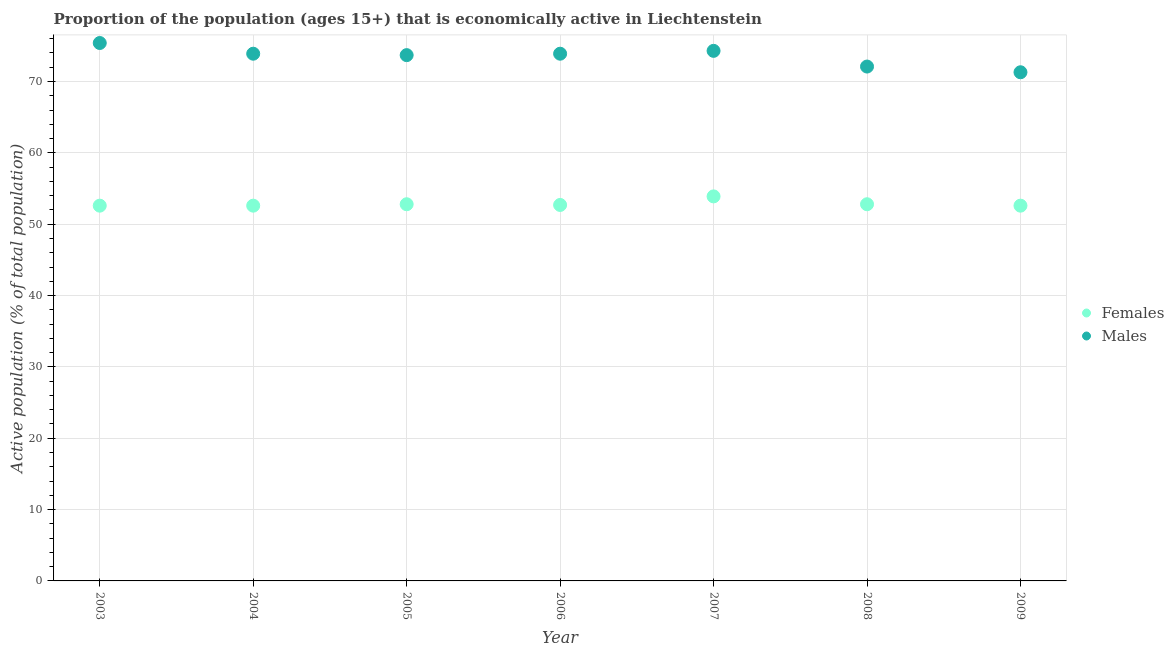How many different coloured dotlines are there?
Give a very brief answer. 2. What is the percentage of economically active male population in 2007?
Your response must be concise. 74.3. Across all years, what is the maximum percentage of economically active female population?
Keep it short and to the point. 53.9. Across all years, what is the minimum percentage of economically active male population?
Your answer should be very brief. 71.3. In which year was the percentage of economically active male population maximum?
Make the answer very short. 2003. In which year was the percentage of economically active female population minimum?
Your answer should be compact. 2003. What is the total percentage of economically active female population in the graph?
Ensure brevity in your answer.  370. What is the difference between the percentage of economically active female population in 2008 and that in 2009?
Offer a very short reply. 0.2. What is the difference between the percentage of economically active female population in 2004 and the percentage of economically active male population in 2005?
Keep it short and to the point. -21.1. What is the average percentage of economically active male population per year?
Offer a terse response. 73.51. In the year 2003, what is the difference between the percentage of economically active female population and percentage of economically active male population?
Ensure brevity in your answer.  -22.8. In how many years, is the percentage of economically active male population greater than 38 %?
Your answer should be very brief. 7. What is the ratio of the percentage of economically active female population in 2004 to that in 2006?
Provide a succinct answer. 1. Is the percentage of economically active female population in 2006 less than that in 2009?
Provide a succinct answer. No. What is the difference between the highest and the second highest percentage of economically active female population?
Offer a very short reply. 1.1. What is the difference between the highest and the lowest percentage of economically active male population?
Give a very brief answer. 4.1. Is the sum of the percentage of economically active male population in 2005 and 2009 greater than the maximum percentage of economically active female population across all years?
Provide a succinct answer. Yes. Is the percentage of economically active male population strictly greater than the percentage of economically active female population over the years?
Provide a short and direct response. Yes. Is the percentage of economically active male population strictly less than the percentage of economically active female population over the years?
Ensure brevity in your answer.  No. How many dotlines are there?
Keep it short and to the point. 2. How are the legend labels stacked?
Provide a short and direct response. Vertical. What is the title of the graph?
Give a very brief answer. Proportion of the population (ages 15+) that is economically active in Liechtenstein. Does "IMF concessional" appear as one of the legend labels in the graph?
Make the answer very short. No. What is the label or title of the Y-axis?
Make the answer very short. Active population (% of total population). What is the Active population (% of total population) of Females in 2003?
Make the answer very short. 52.6. What is the Active population (% of total population) in Males in 2003?
Provide a succinct answer. 75.4. What is the Active population (% of total population) of Females in 2004?
Offer a very short reply. 52.6. What is the Active population (% of total population) in Males in 2004?
Your answer should be compact. 73.9. What is the Active population (% of total population) of Females in 2005?
Give a very brief answer. 52.8. What is the Active population (% of total population) of Males in 2005?
Your answer should be very brief. 73.7. What is the Active population (% of total population) in Females in 2006?
Make the answer very short. 52.7. What is the Active population (% of total population) in Males in 2006?
Offer a terse response. 73.9. What is the Active population (% of total population) in Females in 2007?
Make the answer very short. 53.9. What is the Active population (% of total population) in Males in 2007?
Offer a very short reply. 74.3. What is the Active population (% of total population) in Females in 2008?
Ensure brevity in your answer.  52.8. What is the Active population (% of total population) in Males in 2008?
Give a very brief answer. 72.1. What is the Active population (% of total population) of Females in 2009?
Your response must be concise. 52.6. What is the Active population (% of total population) in Males in 2009?
Offer a very short reply. 71.3. Across all years, what is the maximum Active population (% of total population) in Females?
Ensure brevity in your answer.  53.9. Across all years, what is the maximum Active population (% of total population) of Males?
Make the answer very short. 75.4. Across all years, what is the minimum Active population (% of total population) of Females?
Your answer should be compact. 52.6. Across all years, what is the minimum Active population (% of total population) of Males?
Make the answer very short. 71.3. What is the total Active population (% of total population) of Females in the graph?
Offer a very short reply. 370. What is the total Active population (% of total population) in Males in the graph?
Keep it short and to the point. 514.6. What is the difference between the Active population (% of total population) of Females in 2003 and that in 2005?
Provide a short and direct response. -0.2. What is the difference between the Active population (% of total population) of Females in 2003 and that in 2007?
Your answer should be compact. -1.3. What is the difference between the Active population (% of total population) in Females in 2003 and that in 2008?
Give a very brief answer. -0.2. What is the difference between the Active population (% of total population) of Females in 2003 and that in 2009?
Offer a terse response. 0. What is the difference between the Active population (% of total population) in Males in 2004 and that in 2006?
Provide a succinct answer. 0. What is the difference between the Active population (% of total population) of Males in 2004 and that in 2007?
Provide a succinct answer. -0.4. What is the difference between the Active population (% of total population) of Males in 2004 and that in 2009?
Offer a very short reply. 2.6. What is the difference between the Active population (% of total population) in Females in 2005 and that in 2009?
Provide a short and direct response. 0.2. What is the difference between the Active population (% of total population) in Males in 2006 and that in 2007?
Provide a succinct answer. -0.4. What is the difference between the Active population (% of total population) in Males in 2006 and that in 2008?
Provide a short and direct response. 1.8. What is the difference between the Active population (% of total population) of Males in 2007 and that in 2008?
Ensure brevity in your answer.  2.2. What is the difference between the Active population (% of total population) of Females in 2007 and that in 2009?
Provide a succinct answer. 1.3. What is the difference between the Active population (% of total population) in Males in 2007 and that in 2009?
Provide a short and direct response. 3. What is the difference between the Active population (% of total population) in Females in 2003 and the Active population (% of total population) in Males in 2004?
Ensure brevity in your answer.  -21.3. What is the difference between the Active population (% of total population) of Females in 2003 and the Active population (% of total population) of Males in 2005?
Provide a succinct answer. -21.1. What is the difference between the Active population (% of total population) of Females in 2003 and the Active population (% of total population) of Males in 2006?
Offer a terse response. -21.3. What is the difference between the Active population (% of total population) of Females in 2003 and the Active population (% of total population) of Males in 2007?
Your response must be concise. -21.7. What is the difference between the Active population (% of total population) of Females in 2003 and the Active population (% of total population) of Males in 2008?
Provide a short and direct response. -19.5. What is the difference between the Active population (% of total population) of Females in 2003 and the Active population (% of total population) of Males in 2009?
Provide a succinct answer. -18.7. What is the difference between the Active population (% of total population) in Females in 2004 and the Active population (% of total population) in Males in 2005?
Ensure brevity in your answer.  -21.1. What is the difference between the Active population (% of total population) of Females in 2004 and the Active population (% of total population) of Males in 2006?
Make the answer very short. -21.3. What is the difference between the Active population (% of total population) of Females in 2004 and the Active population (% of total population) of Males in 2007?
Make the answer very short. -21.7. What is the difference between the Active population (% of total population) of Females in 2004 and the Active population (% of total population) of Males in 2008?
Offer a terse response. -19.5. What is the difference between the Active population (% of total population) of Females in 2004 and the Active population (% of total population) of Males in 2009?
Make the answer very short. -18.7. What is the difference between the Active population (% of total population) of Females in 2005 and the Active population (% of total population) of Males in 2006?
Provide a succinct answer. -21.1. What is the difference between the Active population (% of total population) of Females in 2005 and the Active population (% of total population) of Males in 2007?
Your response must be concise. -21.5. What is the difference between the Active population (% of total population) in Females in 2005 and the Active population (% of total population) in Males in 2008?
Give a very brief answer. -19.3. What is the difference between the Active population (% of total population) in Females in 2005 and the Active population (% of total population) in Males in 2009?
Your response must be concise. -18.5. What is the difference between the Active population (% of total population) in Females in 2006 and the Active population (% of total population) in Males in 2007?
Keep it short and to the point. -21.6. What is the difference between the Active population (% of total population) in Females in 2006 and the Active population (% of total population) in Males in 2008?
Your answer should be very brief. -19.4. What is the difference between the Active population (% of total population) of Females in 2006 and the Active population (% of total population) of Males in 2009?
Give a very brief answer. -18.6. What is the difference between the Active population (% of total population) of Females in 2007 and the Active population (% of total population) of Males in 2008?
Your response must be concise. -18.2. What is the difference between the Active population (% of total population) of Females in 2007 and the Active population (% of total population) of Males in 2009?
Give a very brief answer. -17.4. What is the difference between the Active population (% of total population) in Females in 2008 and the Active population (% of total population) in Males in 2009?
Your answer should be compact. -18.5. What is the average Active population (% of total population) in Females per year?
Keep it short and to the point. 52.86. What is the average Active population (% of total population) of Males per year?
Offer a very short reply. 73.51. In the year 2003, what is the difference between the Active population (% of total population) in Females and Active population (% of total population) in Males?
Provide a succinct answer. -22.8. In the year 2004, what is the difference between the Active population (% of total population) in Females and Active population (% of total population) in Males?
Your answer should be very brief. -21.3. In the year 2005, what is the difference between the Active population (% of total population) of Females and Active population (% of total population) of Males?
Your answer should be compact. -20.9. In the year 2006, what is the difference between the Active population (% of total population) in Females and Active population (% of total population) in Males?
Ensure brevity in your answer.  -21.2. In the year 2007, what is the difference between the Active population (% of total population) of Females and Active population (% of total population) of Males?
Provide a succinct answer. -20.4. In the year 2008, what is the difference between the Active population (% of total population) in Females and Active population (% of total population) in Males?
Keep it short and to the point. -19.3. In the year 2009, what is the difference between the Active population (% of total population) in Females and Active population (% of total population) in Males?
Keep it short and to the point. -18.7. What is the ratio of the Active population (% of total population) in Females in 2003 to that in 2004?
Provide a succinct answer. 1. What is the ratio of the Active population (% of total population) in Males in 2003 to that in 2004?
Provide a succinct answer. 1.02. What is the ratio of the Active population (% of total population) of Males in 2003 to that in 2005?
Your answer should be very brief. 1.02. What is the ratio of the Active population (% of total population) in Females in 2003 to that in 2006?
Your answer should be compact. 1. What is the ratio of the Active population (% of total population) in Males in 2003 to that in 2006?
Your answer should be compact. 1.02. What is the ratio of the Active population (% of total population) of Females in 2003 to that in 2007?
Your answer should be compact. 0.98. What is the ratio of the Active population (% of total population) of Males in 2003 to that in 2007?
Give a very brief answer. 1.01. What is the ratio of the Active population (% of total population) of Females in 2003 to that in 2008?
Your response must be concise. 1. What is the ratio of the Active population (% of total population) of Males in 2003 to that in 2008?
Provide a short and direct response. 1.05. What is the ratio of the Active population (% of total population) of Males in 2003 to that in 2009?
Your response must be concise. 1.06. What is the ratio of the Active population (% of total population) of Females in 2004 to that in 2005?
Your response must be concise. 1. What is the ratio of the Active population (% of total population) in Males in 2004 to that in 2006?
Ensure brevity in your answer.  1. What is the ratio of the Active population (% of total population) of Females in 2004 to that in 2007?
Your answer should be compact. 0.98. What is the ratio of the Active population (% of total population) of Females in 2004 to that in 2009?
Your response must be concise. 1. What is the ratio of the Active population (% of total population) in Males in 2004 to that in 2009?
Provide a short and direct response. 1.04. What is the ratio of the Active population (% of total population) of Females in 2005 to that in 2006?
Your answer should be very brief. 1. What is the ratio of the Active population (% of total population) in Males in 2005 to that in 2006?
Your response must be concise. 1. What is the ratio of the Active population (% of total population) in Females in 2005 to that in 2007?
Your response must be concise. 0.98. What is the ratio of the Active population (% of total population) of Males in 2005 to that in 2007?
Provide a short and direct response. 0.99. What is the ratio of the Active population (% of total population) in Males in 2005 to that in 2008?
Your response must be concise. 1.02. What is the ratio of the Active population (% of total population) in Females in 2005 to that in 2009?
Provide a succinct answer. 1. What is the ratio of the Active population (% of total population) in Males in 2005 to that in 2009?
Make the answer very short. 1.03. What is the ratio of the Active population (% of total population) in Females in 2006 to that in 2007?
Provide a succinct answer. 0.98. What is the ratio of the Active population (% of total population) in Males in 2006 to that in 2007?
Make the answer very short. 0.99. What is the ratio of the Active population (% of total population) of Females in 2006 to that in 2008?
Offer a very short reply. 1. What is the ratio of the Active population (% of total population) of Males in 2006 to that in 2008?
Give a very brief answer. 1.02. What is the ratio of the Active population (% of total population) of Males in 2006 to that in 2009?
Offer a terse response. 1.04. What is the ratio of the Active population (% of total population) of Females in 2007 to that in 2008?
Provide a short and direct response. 1.02. What is the ratio of the Active population (% of total population) in Males in 2007 to that in 2008?
Keep it short and to the point. 1.03. What is the ratio of the Active population (% of total population) in Females in 2007 to that in 2009?
Your response must be concise. 1.02. What is the ratio of the Active population (% of total population) of Males in 2007 to that in 2009?
Provide a short and direct response. 1.04. What is the ratio of the Active population (% of total population) of Males in 2008 to that in 2009?
Keep it short and to the point. 1.01. What is the difference between the highest and the second highest Active population (% of total population) in Females?
Ensure brevity in your answer.  1.1. What is the difference between the highest and the lowest Active population (% of total population) of Males?
Your answer should be very brief. 4.1. 